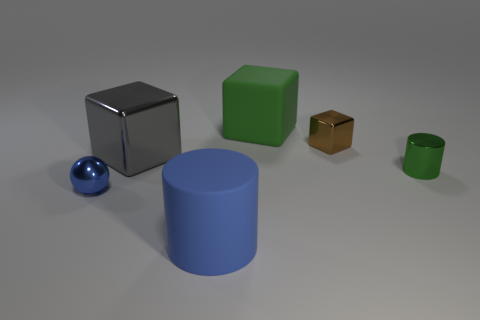What is the color of the tiny shiny cylinder?
Your response must be concise. Green. Is there anything else that is the same material as the small brown thing?
Offer a terse response. Yes. Is the number of large green matte things in front of the big blue object less than the number of cubes that are right of the tiny cylinder?
Provide a short and direct response. No. What is the shape of the metal object that is right of the large green cube and behind the green shiny thing?
Make the answer very short. Cube. How many green rubber things are the same shape as the brown object?
Give a very brief answer. 1. What is the size of the gray object that is the same material as the small cylinder?
Your answer should be very brief. Large. What number of green matte cubes have the same size as the blue metallic sphere?
Provide a succinct answer. 0. The cube that is the same color as the tiny cylinder is what size?
Provide a succinct answer. Large. There is a shiny object that is in front of the green thing that is in front of the brown shiny object; what color is it?
Offer a very short reply. Blue. Are there any tiny shiny objects that have the same color as the small block?
Keep it short and to the point. No. 